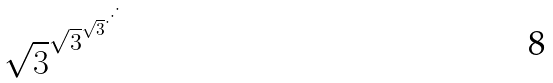<formula> <loc_0><loc_0><loc_500><loc_500>\sqrt { 3 } ^ { \sqrt { 3 } ^ { \sqrt { 3 } ^ { \cdot ^ { \cdot ^ { \cdot } } } } }</formula> 